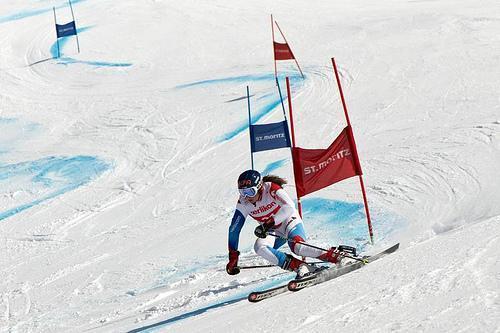How many players?
Give a very brief answer. 1. 